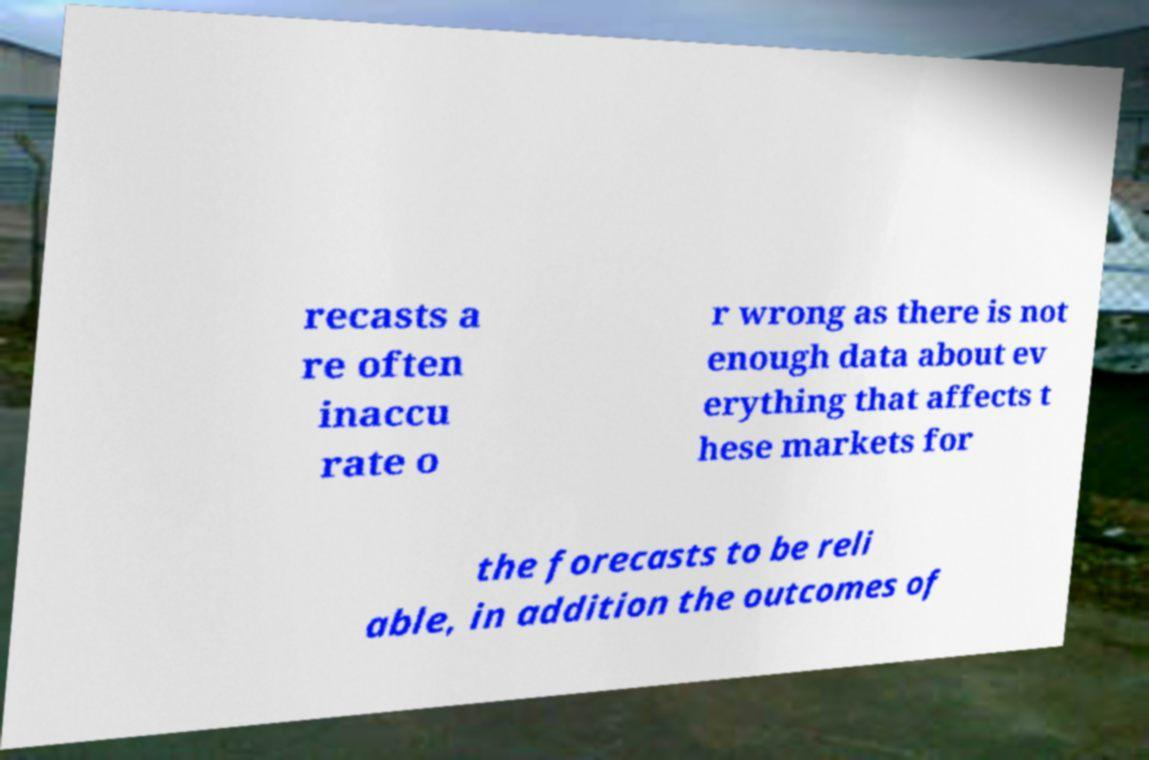For documentation purposes, I need the text within this image transcribed. Could you provide that? recasts a re often inaccu rate o r wrong as there is not enough data about ev erything that affects t hese markets for the forecasts to be reli able, in addition the outcomes of 